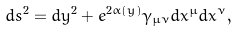Convert formula to latex. <formula><loc_0><loc_0><loc_500><loc_500>d s ^ { 2 } = d y ^ { 2 } + e ^ { 2 \alpha ( y ) } \gamma _ { \mu \nu } d x ^ { \mu } d x ^ { \nu } ,</formula> 